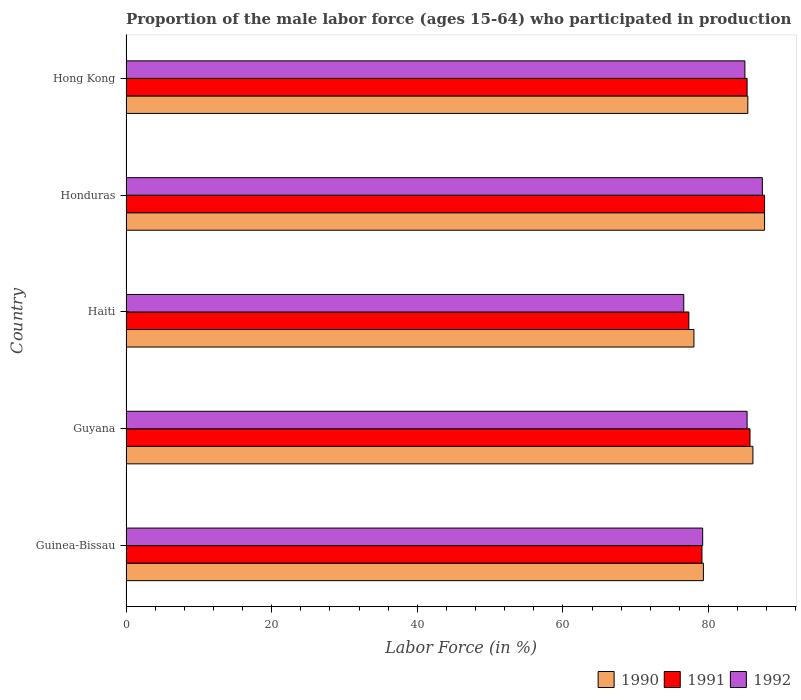How many bars are there on the 3rd tick from the top?
Provide a short and direct response. 3. What is the label of the 1st group of bars from the top?
Provide a succinct answer. Hong Kong. In how many cases, is the number of bars for a given country not equal to the number of legend labels?
Your response must be concise. 0. What is the proportion of the male labor force who participated in production in 1990 in Honduras?
Give a very brief answer. 87.7. Across all countries, what is the maximum proportion of the male labor force who participated in production in 1990?
Ensure brevity in your answer.  87.7. Across all countries, what is the minimum proportion of the male labor force who participated in production in 1990?
Provide a succinct answer. 78. In which country was the proportion of the male labor force who participated in production in 1991 maximum?
Make the answer very short. Honduras. In which country was the proportion of the male labor force who participated in production in 1991 minimum?
Your answer should be very brief. Haiti. What is the total proportion of the male labor force who participated in production in 1991 in the graph?
Make the answer very short. 415.1. What is the difference between the proportion of the male labor force who participated in production in 1990 in Guinea-Bissau and that in Guyana?
Offer a terse response. -6.8. What is the difference between the proportion of the male labor force who participated in production in 1990 in Hong Kong and the proportion of the male labor force who participated in production in 1991 in Guinea-Bissau?
Offer a very short reply. 6.3. What is the average proportion of the male labor force who participated in production in 1991 per country?
Ensure brevity in your answer.  83.02. What is the difference between the proportion of the male labor force who participated in production in 1992 and proportion of the male labor force who participated in production in 1990 in Honduras?
Your answer should be very brief. -0.3. In how many countries, is the proportion of the male labor force who participated in production in 1991 greater than 44 %?
Provide a short and direct response. 5. What is the ratio of the proportion of the male labor force who participated in production in 1992 in Guinea-Bissau to that in Hong Kong?
Give a very brief answer. 0.93. Is the difference between the proportion of the male labor force who participated in production in 1992 in Guinea-Bissau and Guyana greater than the difference between the proportion of the male labor force who participated in production in 1990 in Guinea-Bissau and Guyana?
Provide a short and direct response. Yes. What is the difference between the highest and the second highest proportion of the male labor force who participated in production in 1991?
Your response must be concise. 2. What is the difference between the highest and the lowest proportion of the male labor force who participated in production in 1991?
Give a very brief answer. 10.4. What does the 3rd bar from the bottom in Hong Kong represents?
Offer a terse response. 1992. Is it the case that in every country, the sum of the proportion of the male labor force who participated in production in 1990 and proportion of the male labor force who participated in production in 1992 is greater than the proportion of the male labor force who participated in production in 1991?
Your answer should be compact. Yes. How many bars are there?
Offer a very short reply. 15. Are all the bars in the graph horizontal?
Give a very brief answer. Yes. What is the difference between two consecutive major ticks on the X-axis?
Offer a terse response. 20. Are the values on the major ticks of X-axis written in scientific E-notation?
Ensure brevity in your answer.  No. Does the graph contain any zero values?
Make the answer very short. No. Where does the legend appear in the graph?
Your response must be concise. Bottom right. How many legend labels are there?
Ensure brevity in your answer.  3. How are the legend labels stacked?
Offer a very short reply. Horizontal. What is the title of the graph?
Provide a succinct answer. Proportion of the male labor force (ages 15-64) who participated in production. Does "1982" appear as one of the legend labels in the graph?
Provide a short and direct response. No. What is the label or title of the X-axis?
Provide a succinct answer. Labor Force (in %). What is the label or title of the Y-axis?
Your answer should be compact. Country. What is the Labor Force (in %) of 1990 in Guinea-Bissau?
Provide a short and direct response. 79.3. What is the Labor Force (in %) in 1991 in Guinea-Bissau?
Provide a succinct answer. 79.1. What is the Labor Force (in %) of 1992 in Guinea-Bissau?
Give a very brief answer. 79.2. What is the Labor Force (in %) in 1990 in Guyana?
Your answer should be compact. 86.1. What is the Labor Force (in %) in 1991 in Guyana?
Ensure brevity in your answer.  85.7. What is the Labor Force (in %) of 1992 in Guyana?
Your answer should be very brief. 85.3. What is the Labor Force (in %) of 1991 in Haiti?
Offer a very short reply. 77.3. What is the Labor Force (in %) in 1992 in Haiti?
Provide a short and direct response. 76.6. What is the Labor Force (in %) of 1990 in Honduras?
Your answer should be compact. 87.7. What is the Labor Force (in %) of 1991 in Honduras?
Your response must be concise. 87.7. What is the Labor Force (in %) in 1992 in Honduras?
Offer a very short reply. 87.4. What is the Labor Force (in %) of 1990 in Hong Kong?
Provide a succinct answer. 85.4. What is the Labor Force (in %) in 1991 in Hong Kong?
Provide a short and direct response. 85.3. What is the Labor Force (in %) of 1992 in Hong Kong?
Your response must be concise. 85. Across all countries, what is the maximum Labor Force (in %) in 1990?
Provide a short and direct response. 87.7. Across all countries, what is the maximum Labor Force (in %) in 1991?
Your answer should be compact. 87.7. Across all countries, what is the maximum Labor Force (in %) of 1992?
Provide a succinct answer. 87.4. Across all countries, what is the minimum Labor Force (in %) of 1990?
Offer a very short reply. 78. Across all countries, what is the minimum Labor Force (in %) in 1991?
Provide a short and direct response. 77.3. Across all countries, what is the minimum Labor Force (in %) in 1992?
Ensure brevity in your answer.  76.6. What is the total Labor Force (in %) of 1990 in the graph?
Give a very brief answer. 416.5. What is the total Labor Force (in %) of 1991 in the graph?
Offer a terse response. 415.1. What is the total Labor Force (in %) in 1992 in the graph?
Offer a terse response. 413.5. What is the difference between the Labor Force (in %) in 1992 in Guinea-Bissau and that in Guyana?
Your answer should be very brief. -6.1. What is the difference between the Labor Force (in %) of 1990 in Guinea-Bissau and that in Haiti?
Offer a terse response. 1.3. What is the difference between the Labor Force (in %) in 1991 in Guinea-Bissau and that in Haiti?
Keep it short and to the point. 1.8. What is the difference between the Labor Force (in %) in 1992 in Guinea-Bissau and that in Haiti?
Provide a succinct answer. 2.6. What is the difference between the Labor Force (in %) of 1991 in Guinea-Bissau and that in Honduras?
Keep it short and to the point. -8.6. What is the difference between the Labor Force (in %) of 1990 in Guinea-Bissau and that in Hong Kong?
Ensure brevity in your answer.  -6.1. What is the difference between the Labor Force (in %) in 1990 in Guyana and that in Haiti?
Give a very brief answer. 8.1. What is the difference between the Labor Force (in %) in 1991 in Guyana and that in Haiti?
Give a very brief answer. 8.4. What is the difference between the Labor Force (in %) of 1991 in Guyana and that in Honduras?
Keep it short and to the point. -2. What is the difference between the Labor Force (in %) in 1991 in Guyana and that in Hong Kong?
Your answer should be very brief. 0.4. What is the difference between the Labor Force (in %) in 1992 in Haiti and that in Honduras?
Keep it short and to the point. -10.8. What is the difference between the Labor Force (in %) in 1992 in Haiti and that in Hong Kong?
Provide a succinct answer. -8.4. What is the difference between the Labor Force (in %) of 1990 in Honduras and that in Hong Kong?
Make the answer very short. 2.3. What is the difference between the Labor Force (in %) of 1990 in Guinea-Bissau and the Labor Force (in %) of 1991 in Honduras?
Give a very brief answer. -8.4. What is the difference between the Labor Force (in %) of 1990 in Guinea-Bissau and the Labor Force (in %) of 1992 in Honduras?
Make the answer very short. -8.1. What is the difference between the Labor Force (in %) in 1991 in Guinea-Bissau and the Labor Force (in %) in 1992 in Hong Kong?
Ensure brevity in your answer.  -5.9. What is the difference between the Labor Force (in %) in 1990 in Guyana and the Labor Force (in %) in 1991 in Haiti?
Provide a succinct answer. 8.8. What is the difference between the Labor Force (in %) of 1990 in Guyana and the Labor Force (in %) of 1992 in Honduras?
Offer a very short reply. -1.3. What is the difference between the Labor Force (in %) in 1990 in Guyana and the Labor Force (in %) in 1992 in Hong Kong?
Offer a very short reply. 1.1. What is the difference between the Labor Force (in %) in 1991 in Guyana and the Labor Force (in %) in 1992 in Hong Kong?
Keep it short and to the point. 0.7. What is the difference between the Labor Force (in %) of 1990 in Haiti and the Labor Force (in %) of 1991 in Honduras?
Provide a succinct answer. -9.7. What is the difference between the Labor Force (in %) in 1990 in Haiti and the Labor Force (in %) in 1991 in Hong Kong?
Offer a terse response. -7.3. What is the difference between the Labor Force (in %) in 1991 in Haiti and the Labor Force (in %) in 1992 in Hong Kong?
Give a very brief answer. -7.7. What is the difference between the Labor Force (in %) in 1991 in Honduras and the Labor Force (in %) in 1992 in Hong Kong?
Your response must be concise. 2.7. What is the average Labor Force (in %) of 1990 per country?
Offer a very short reply. 83.3. What is the average Labor Force (in %) in 1991 per country?
Make the answer very short. 83.02. What is the average Labor Force (in %) in 1992 per country?
Your answer should be compact. 82.7. What is the difference between the Labor Force (in %) in 1990 and Labor Force (in %) in 1991 in Guyana?
Give a very brief answer. 0.4. What is the difference between the Labor Force (in %) of 1990 and Labor Force (in %) of 1991 in Haiti?
Provide a succinct answer. 0.7. What is the difference between the Labor Force (in %) in 1990 and Labor Force (in %) in 1991 in Honduras?
Keep it short and to the point. 0. What is the difference between the Labor Force (in %) of 1991 and Labor Force (in %) of 1992 in Honduras?
Offer a very short reply. 0.3. What is the difference between the Labor Force (in %) in 1990 and Labor Force (in %) in 1991 in Hong Kong?
Make the answer very short. 0.1. What is the difference between the Labor Force (in %) in 1990 and Labor Force (in %) in 1992 in Hong Kong?
Your answer should be compact. 0.4. What is the ratio of the Labor Force (in %) of 1990 in Guinea-Bissau to that in Guyana?
Offer a terse response. 0.92. What is the ratio of the Labor Force (in %) in 1991 in Guinea-Bissau to that in Guyana?
Your response must be concise. 0.92. What is the ratio of the Labor Force (in %) in 1992 in Guinea-Bissau to that in Guyana?
Provide a short and direct response. 0.93. What is the ratio of the Labor Force (in %) in 1990 in Guinea-Bissau to that in Haiti?
Ensure brevity in your answer.  1.02. What is the ratio of the Labor Force (in %) of 1991 in Guinea-Bissau to that in Haiti?
Ensure brevity in your answer.  1.02. What is the ratio of the Labor Force (in %) of 1992 in Guinea-Bissau to that in Haiti?
Provide a short and direct response. 1.03. What is the ratio of the Labor Force (in %) of 1990 in Guinea-Bissau to that in Honduras?
Make the answer very short. 0.9. What is the ratio of the Labor Force (in %) in 1991 in Guinea-Bissau to that in Honduras?
Give a very brief answer. 0.9. What is the ratio of the Labor Force (in %) of 1992 in Guinea-Bissau to that in Honduras?
Give a very brief answer. 0.91. What is the ratio of the Labor Force (in %) in 1991 in Guinea-Bissau to that in Hong Kong?
Keep it short and to the point. 0.93. What is the ratio of the Labor Force (in %) in 1992 in Guinea-Bissau to that in Hong Kong?
Make the answer very short. 0.93. What is the ratio of the Labor Force (in %) in 1990 in Guyana to that in Haiti?
Offer a very short reply. 1.1. What is the ratio of the Labor Force (in %) in 1991 in Guyana to that in Haiti?
Give a very brief answer. 1.11. What is the ratio of the Labor Force (in %) of 1992 in Guyana to that in Haiti?
Your answer should be very brief. 1.11. What is the ratio of the Labor Force (in %) of 1990 in Guyana to that in Honduras?
Give a very brief answer. 0.98. What is the ratio of the Labor Force (in %) of 1991 in Guyana to that in Honduras?
Offer a very short reply. 0.98. What is the ratio of the Labor Force (in %) of 1990 in Guyana to that in Hong Kong?
Your answer should be compact. 1.01. What is the ratio of the Labor Force (in %) of 1990 in Haiti to that in Honduras?
Provide a succinct answer. 0.89. What is the ratio of the Labor Force (in %) in 1991 in Haiti to that in Honduras?
Keep it short and to the point. 0.88. What is the ratio of the Labor Force (in %) in 1992 in Haiti to that in Honduras?
Your answer should be very brief. 0.88. What is the ratio of the Labor Force (in %) in 1990 in Haiti to that in Hong Kong?
Make the answer very short. 0.91. What is the ratio of the Labor Force (in %) in 1991 in Haiti to that in Hong Kong?
Give a very brief answer. 0.91. What is the ratio of the Labor Force (in %) in 1992 in Haiti to that in Hong Kong?
Provide a succinct answer. 0.9. What is the ratio of the Labor Force (in %) in 1990 in Honduras to that in Hong Kong?
Your answer should be very brief. 1.03. What is the ratio of the Labor Force (in %) in 1991 in Honduras to that in Hong Kong?
Your answer should be compact. 1.03. What is the ratio of the Labor Force (in %) in 1992 in Honduras to that in Hong Kong?
Offer a terse response. 1.03. What is the difference between the highest and the second highest Labor Force (in %) in 1992?
Your answer should be compact. 2.1. What is the difference between the highest and the lowest Labor Force (in %) of 1991?
Ensure brevity in your answer.  10.4. What is the difference between the highest and the lowest Labor Force (in %) in 1992?
Offer a very short reply. 10.8. 